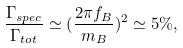Convert formula to latex. <formula><loc_0><loc_0><loc_500><loc_500>\frac { \Gamma _ { s p e c } } { \Gamma _ { t o t } } \simeq ( \frac { 2 \pi f _ { B } } { m _ { B } } ) ^ { 2 } \simeq 5 \% ,</formula> 